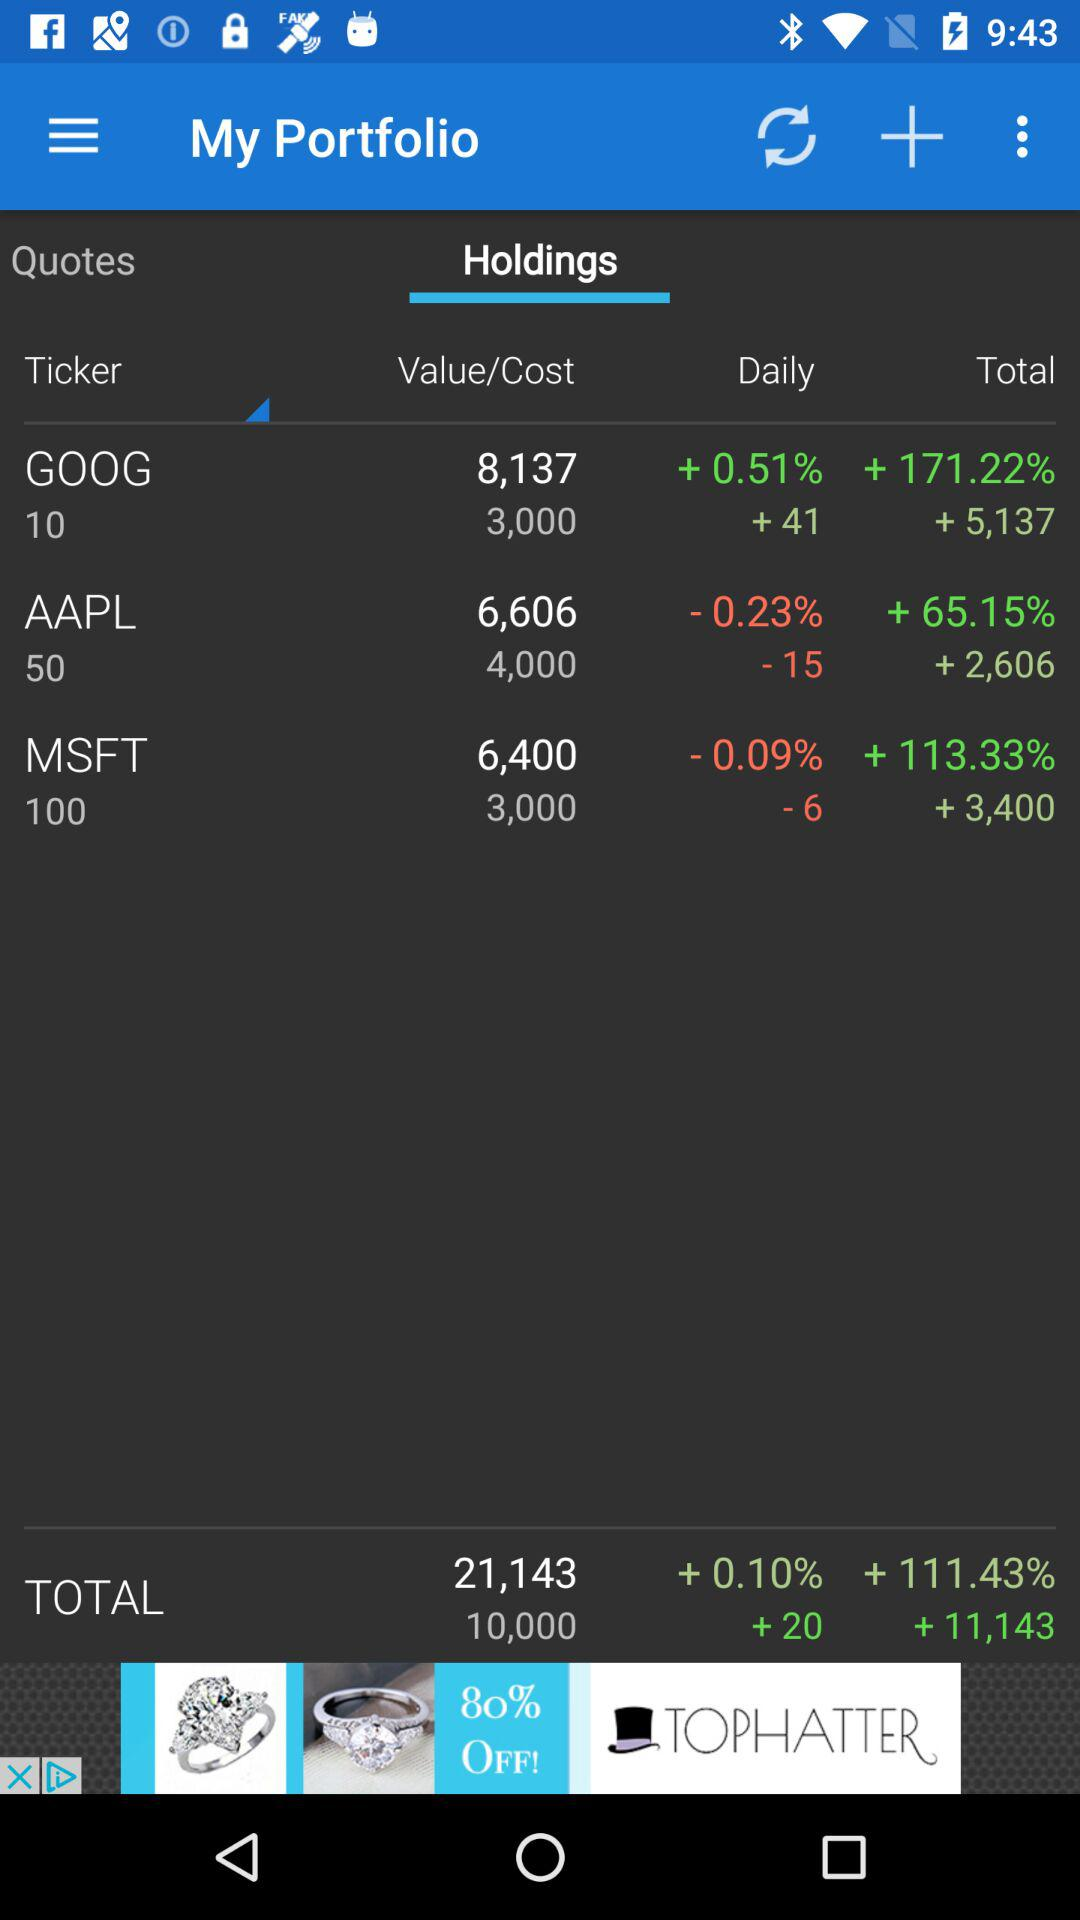What is the percentage change for the total value of all the stocks?
Answer the question using a single word or phrase. +0.10% 